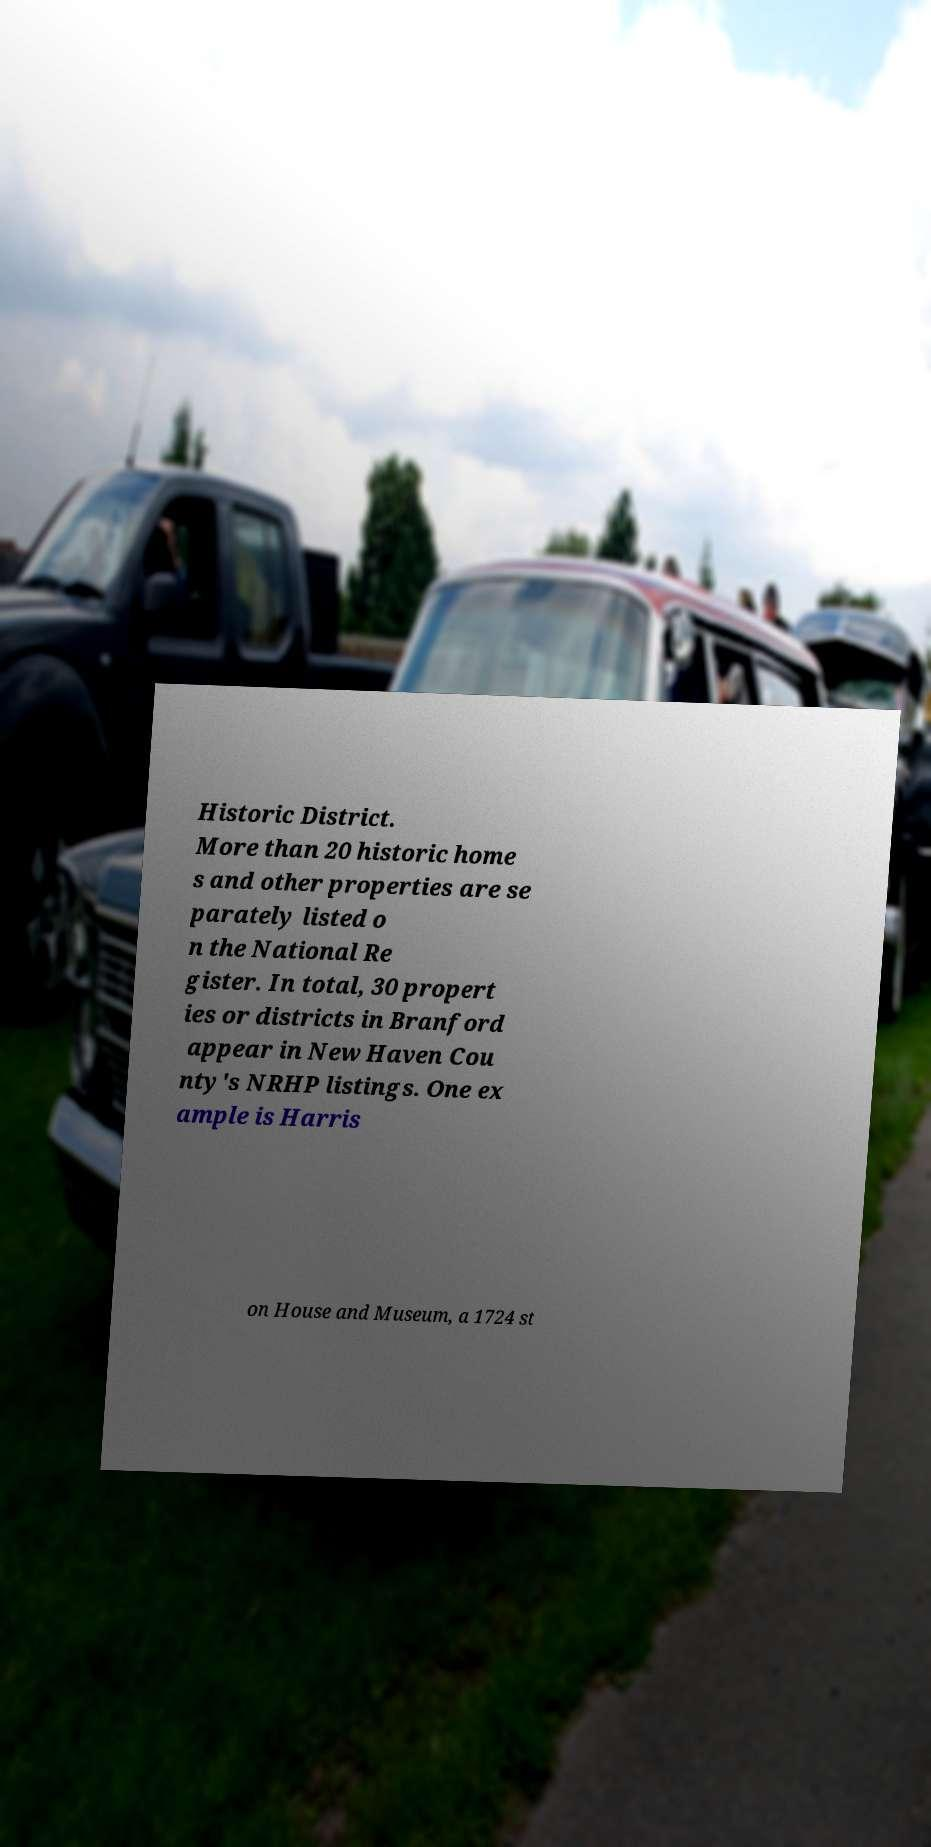What messages or text are displayed in this image? I need them in a readable, typed format. Historic District. More than 20 historic home s and other properties are se parately listed o n the National Re gister. In total, 30 propert ies or districts in Branford appear in New Haven Cou nty's NRHP listings. One ex ample is Harris on House and Museum, a 1724 st 